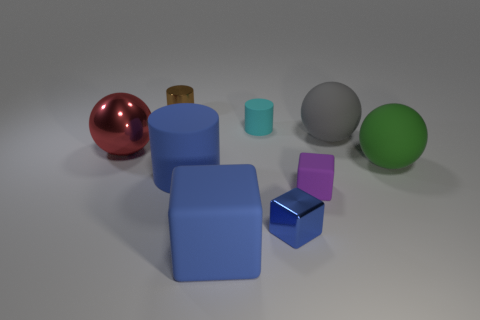Subtract all cubes. How many objects are left? 6 Add 9 brown shiny objects. How many brown shiny objects are left? 10 Add 5 tiny blue objects. How many tiny blue objects exist? 6 Subtract 0 green cubes. How many objects are left? 9 Subtract all big purple metallic blocks. Subtract all purple rubber blocks. How many objects are left? 8 